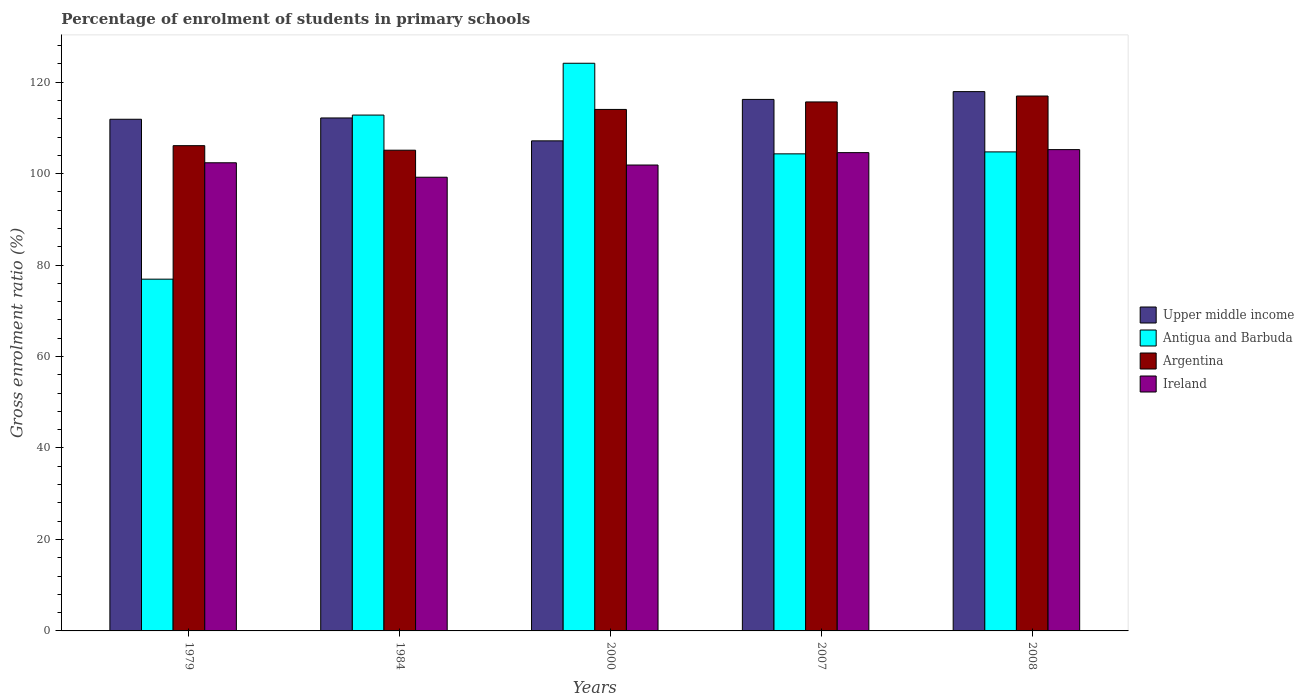Are the number of bars per tick equal to the number of legend labels?
Ensure brevity in your answer.  Yes. How many bars are there on the 4th tick from the left?
Provide a succinct answer. 4. What is the label of the 4th group of bars from the left?
Your answer should be compact. 2007. In how many cases, is the number of bars for a given year not equal to the number of legend labels?
Offer a terse response. 0. What is the percentage of students enrolled in primary schools in Ireland in 2008?
Your answer should be very brief. 105.25. Across all years, what is the maximum percentage of students enrolled in primary schools in Antigua and Barbuda?
Ensure brevity in your answer.  124.13. Across all years, what is the minimum percentage of students enrolled in primary schools in Upper middle income?
Offer a very short reply. 107.16. What is the total percentage of students enrolled in primary schools in Argentina in the graph?
Keep it short and to the point. 557.9. What is the difference between the percentage of students enrolled in primary schools in Upper middle income in 1984 and that in 2008?
Your answer should be compact. -5.76. What is the difference between the percentage of students enrolled in primary schools in Antigua and Barbuda in 2007 and the percentage of students enrolled in primary schools in Upper middle income in 1979?
Give a very brief answer. -7.56. What is the average percentage of students enrolled in primary schools in Ireland per year?
Your answer should be very brief. 102.66. In the year 2007, what is the difference between the percentage of students enrolled in primary schools in Antigua and Barbuda and percentage of students enrolled in primary schools in Ireland?
Make the answer very short. -0.27. In how many years, is the percentage of students enrolled in primary schools in Argentina greater than 64 %?
Ensure brevity in your answer.  5. What is the ratio of the percentage of students enrolled in primary schools in Antigua and Barbuda in 1979 to that in 1984?
Make the answer very short. 0.68. Is the percentage of students enrolled in primary schools in Upper middle income in 2000 less than that in 2007?
Offer a terse response. Yes. Is the difference between the percentage of students enrolled in primary schools in Antigua and Barbuda in 1984 and 2007 greater than the difference between the percentage of students enrolled in primary schools in Ireland in 1984 and 2007?
Offer a terse response. Yes. What is the difference between the highest and the second highest percentage of students enrolled in primary schools in Antigua and Barbuda?
Offer a very short reply. 11.33. What is the difference between the highest and the lowest percentage of students enrolled in primary schools in Ireland?
Offer a terse response. 6.04. Is the sum of the percentage of students enrolled in primary schools in Ireland in 1984 and 2000 greater than the maximum percentage of students enrolled in primary schools in Antigua and Barbuda across all years?
Your answer should be compact. Yes. What does the 1st bar from the left in 1984 represents?
Offer a very short reply. Upper middle income. What does the 4th bar from the right in 1979 represents?
Your response must be concise. Upper middle income. Is it the case that in every year, the sum of the percentage of students enrolled in primary schools in Antigua and Barbuda and percentage of students enrolled in primary schools in Upper middle income is greater than the percentage of students enrolled in primary schools in Ireland?
Give a very brief answer. Yes. Are all the bars in the graph horizontal?
Your answer should be compact. No. Does the graph contain grids?
Your response must be concise. No. How many legend labels are there?
Ensure brevity in your answer.  4. How are the legend labels stacked?
Give a very brief answer. Vertical. What is the title of the graph?
Offer a terse response. Percentage of enrolment of students in primary schools. Does "Macedonia" appear as one of the legend labels in the graph?
Your answer should be very brief. No. What is the Gross enrolment ratio (%) in Upper middle income in 1979?
Your response must be concise. 111.88. What is the Gross enrolment ratio (%) in Antigua and Barbuda in 1979?
Offer a terse response. 76.92. What is the Gross enrolment ratio (%) of Argentina in 1979?
Your response must be concise. 106.11. What is the Gross enrolment ratio (%) in Ireland in 1979?
Offer a terse response. 102.37. What is the Gross enrolment ratio (%) of Upper middle income in 1984?
Your response must be concise. 112.17. What is the Gross enrolment ratio (%) in Antigua and Barbuda in 1984?
Offer a terse response. 112.8. What is the Gross enrolment ratio (%) in Argentina in 1984?
Offer a terse response. 105.12. What is the Gross enrolment ratio (%) of Ireland in 1984?
Make the answer very short. 99.21. What is the Gross enrolment ratio (%) of Upper middle income in 2000?
Give a very brief answer. 107.16. What is the Gross enrolment ratio (%) of Antigua and Barbuda in 2000?
Your answer should be compact. 124.13. What is the Gross enrolment ratio (%) in Argentina in 2000?
Your response must be concise. 114.03. What is the Gross enrolment ratio (%) of Ireland in 2000?
Offer a very short reply. 101.88. What is the Gross enrolment ratio (%) of Upper middle income in 2007?
Your response must be concise. 116.22. What is the Gross enrolment ratio (%) in Antigua and Barbuda in 2007?
Give a very brief answer. 104.32. What is the Gross enrolment ratio (%) in Argentina in 2007?
Your response must be concise. 115.67. What is the Gross enrolment ratio (%) of Ireland in 2007?
Provide a succinct answer. 104.59. What is the Gross enrolment ratio (%) in Upper middle income in 2008?
Your answer should be compact. 117.93. What is the Gross enrolment ratio (%) in Antigua and Barbuda in 2008?
Keep it short and to the point. 104.75. What is the Gross enrolment ratio (%) of Argentina in 2008?
Ensure brevity in your answer.  116.96. What is the Gross enrolment ratio (%) of Ireland in 2008?
Offer a very short reply. 105.25. Across all years, what is the maximum Gross enrolment ratio (%) in Upper middle income?
Provide a succinct answer. 117.93. Across all years, what is the maximum Gross enrolment ratio (%) in Antigua and Barbuda?
Your answer should be very brief. 124.13. Across all years, what is the maximum Gross enrolment ratio (%) of Argentina?
Offer a terse response. 116.96. Across all years, what is the maximum Gross enrolment ratio (%) in Ireland?
Your response must be concise. 105.25. Across all years, what is the minimum Gross enrolment ratio (%) of Upper middle income?
Provide a short and direct response. 107.16. Across all years, what is the minimum Gross enrolment ratio (%) of Antigua and Barbuda?
Your answer should be compact. 76.92. Across all years, what is the minimum Gross enrolment ratio (%) in Argentina?
Give a very brief answer. 105.12. Across all years, what is the minimum Gross enrolment ratio (%) of Ireland?
Give a very brief answer. 99.21. What is the total Gross enrolment ratio (%) of Upper middle income in the graph?
Give a very brief answer. 565.37. What is the total Gross enrolment ratio (%) in Antigua and Barbuda in the graph?
Your answer should be very brief. 522.91. What is the total Gross enrolment ratio (%) in Argentina in the graph?
Keep it short and to the point. 557.9. What is the total Gross enrolment ratio (%) of Ireland in the graph?
Give a very brief answer. 513.29. What is the difference between the Gross enrolment ratio (%) in Upper middle income in 1979 and that in 1984?
Keep it short and to the point. -0.29. What is the difference between the Gross enrolment ratio (%) of Antigua and Barbuda in 1979 and that in 1984?
Provide a succinct answer. -35.88. What is the difference between the Gross enrolment ratio (%) of Ireland in 1979 and that in 1984?
Your answer should be compact. 3.16. What is the difference between the Gross enrolment ratio (%) of Upper middle income in 1979 and that in 2000?
Ensure brevity in your answer.  4.72. What is the difference between the Gross enrolment ratio (%) of Antigua and Barbuda in 1979 and that in 2000?
Ensure brevity in your answer.  -47.21. What is the difference between the Gross enrolment ratio (%) in Argentina in 1979 and that in 2000?
Ensure brevity in your answer.  -7.92. What is the difference between the Gross enrolment ratio (%) of Ireland in 1979 and that in 2000?
Offer a terse response. 0.49. What is the difference between the Gross enrolment ratio (%) of Upper middle income in 1979 and that in 2007?
Offer a very short reply. -4.34. What is the difference between the Gross enrolment ratio (%) of Antigua and Barbuda in 1979 and that in 2007?
Give a very brief answer. -27.4. What is the difference between the Gross enrolment ratio (%) of Argentina in 1979 and that in 2007?
Keep it short and to the point. -9.56. What is the difference between the Gross enrolment ratio (%) of Ireland in 1979 and that in 2007?
Give a very brief answer. -2.22. What is the difference between the Gross enrolment ratio (%) of Upper middle income in 1979 and that in 2008?
Make the answer very short. -6.05. What is the difference between the Gross enrolment ratio (%) in Antigua and Barbuda in 1979 and that in 2008?
Your answer should be very brief. -27.83. What is the difference between the Gross enrolment ratio (%) of Argentina in 1979 and that in 2008?
Offer a terse response. -10.85. What is the difference between the Gross enrolment ratio (%) of Ireland in 1979 and that in 2008?
Make the answer very short. -2.88. What is the difference between the Gross enrolment ratio (%) in Upper middle income in 1984 and that in 2000?
Your answer should be very brief. 5. What is the difference between the Gross enrolment ratio (%) of Antigua and Barbuda in 1984 and that in 2000?
Provide a succinct answer. -11.33. What is the difference between the Gross enrolment ratio (%) in Argentina in 1984 and that in 2000?
Your answer should be compact. -8.91. What is the difference between the Gross enrolment ratio (%) in Ireland in 1984 and that in 2000?
Your answer should be compact. -2.67. What is the difference between the Gross enrolment ratio (%) of Upper middle income in 1984 and that in 2007?
Keep it short and to the point. -4.06. What is the difference between the Gross enrolment ratio (%) of Antigua and Barbuda in 1984 and that in 2007?
Your answer should be very brief. 8.48. What is the difference between the Gross enrolment ratio (%) in Argentina in 1984 and that in 2007?
Make the answer very short. -10.55. What is the difference between the Gross enrolment ratio (%) of Ireland in 1984 and that in 2007?
Make the answer very short. -5.38. What is the difference between the Gross enrolment ratio (%) of Upper middle income in 1984 and that in 2008?
Your answer should be very brief. -5.76. What is the difference between the Gross enrolment ratio (%) in Antigua and Barbuda in 1984 and that in 2008?
Make the answer very short. 8.05. What is the difference between the Gross enrolment ratio (%) of Argentina in 1984 and that in 2008?
Your answer should be compact. -11.85. What is the difference between the Gross enrolment ratio (%) of Ireland in 1984 and that in 2008?
Make the answer very short. -6.04. What is the difference between the Gross enrolment ratio (%) of Upper middle income in 2000 and that in 2007?
Provide a succinct answer. -9.06. What is the difference between the Gross enrolment ratio (%) in Antigua and Barbuda in 2000 and that in 2007?
Offer a terse response. 19.81. What is the difference between the Gross enrolment ratio (%) of Argentina in 2000 and that in 2007?
Provide a short and direct response. -1.64. What is the difference between the Gross enrolment ratio (%) of Ireland in 2000 and that in 2007?
Give a very brief answer. -2.71. What is the difference between the Gross enrolment ratio (%) of Upper middle income in 2000 and that in 2008?
Your answer should be very brief. -10.77. What is the difference between the Gross enrolment ratio (%) in Antigua and Barbuda in 2000 and that in 2008?
Offer a very short reply. 19.38. What is the difference between the Gross enrolment ratio (%) of Argentina in 2000 and that in 2008?
Provide a short and direct response. -2.93. What is the difference between the Gross enrolment ratio (%) in Ireland in 2000 and that in 2008?
Your answer should be compact. -3.37. What is the difference between the Gross enrolment ratio (%) of Upper middle income in 2007 and that in 2008?
Offer a terse response. -1.7. What is the difference between the Gross enrolment ratio (%) of Antigua and Barbuda in 2007 and that in 2008?
Offer a terse response. -0.43. What is the difference between the Gross enrolment ratio (%) of Argentina in 2007 and that in 2008?
Your response must be concise. -1.29. What is the difference between the Gross enrolment ratio (%) of Ireland in 2007 and that in 2008?
Make the answer very short. -0.66. What is the difference between the Gross enrolment ratio (%) in Upper middle income in 1979 and the Gross enrolment ratio (%) in Antigua and Barbuda in 1984?
Your answer should be compact. -0.92. What is the difference between the Gross enrolment ratio (%) in Upper middle income in 1979 and the Gross enrolment ratio (%) in Argentina in 1984?
Offer a very short reply. 6.76. What is the difference between the Gross enrolment ratio (%) of Upper middle income in 1979 and the Gross enrolment ratio (%) of Ireland in 1984?
Your answer should be very brief. 12.67. What is the difference between the Gross enrolment ratio (%) of Antigua and Barbuda in 1979 and the Gross enrolment ratio (%) of Argentina in 1984?
Give a very brief answer. -28.2. What is the difference between the Gross enrolment ratio (%) of Antigua and Barbuda in 1979 and the Gross enrolment ratio (%) of Ireland in 1984?
Offer a terse response. -22.29. What is the difference between the Gross enrolment ratio (%) of Argentina in 1979 and the Gross enrolment ratio (%) of Ireland in 1984?
Provide a succinct answer. 6.9. What is the difference between the Gross enrolment ratio (%) of Upper middle income in 1979 and the Gross enrolment ratio (%) of Antigua and Barbuda in 2000?
Your answer should be compact. -12.25. What is the difference between the Gross enrolment ratio (%) in Upper middle income in 1979 and the Gross enrolment ratio (%) in Argentina in 2000?
Keep it short and to the point. -2.15. What is the difference between the Gross enrolment ratio (%) of Upper middle income in 1979 and the Gross enrolment ratio (%) of Ireland in 2000?
Provide a succinct answer. 10.01. What is the difference between the Gross enrolment ratio (%) in Antigua and Barbuda in 1979 and the Gross enrolment ratio (%) in Argentina in 2000?
Your answer should be compact. -37.12. What is the difference between the Gross enrolment ratio (%) of Antigua and Barbuda in 1979 and the Gross enrolment ratio (%) of Ireland in 2000?
Your response must be concise. -24.96. What is the difference between the Gross enrolment ratio (%) of Argentina in 1979 and the Gross enrolment ratio (%) of Ireland in 2000?
Offer a terse response. 4.23. What is the difference between the Gross enrolment ratio (%) in Upper middle income in 1979 and the Gross enrolment ratio (%) in Antigua and Barbuda in 2007?
Provide a short and direct response. 7.56. What is the difference between the Gross enrolment ratio (%) of Upper middle income in 1979 and the Gross enrolment ratio (%) of Argentina in 2007?
Make the answer very short. -3.79. What is the difference between the Gross enrolment ratio (%) of Upper middle income in 1979 and the Gross enrolment ratio (%) of Ireland in 2007?
Your answer should be compact. 7.3. What is the difference between the Gross enrolment ratio (%) in Antigua and Barbuda in 1979 and the Gross enrolment ratio (%) in Argentina in 2007?
Make the answer very short. -38.76. What is the difference between the Gross enrolment ratio (%) of Antigua and Barbuda in 1979 and the Gross enrolment ratio (%) of Ireland in 2007?
Your answer should be compact. -27.67. What is the difference between the Gross enrolment ratio (%) of Argentina in 1979 and the Gross enrolment ratio (%) of Ireland in 2007?
Your answer should be compact. 1.52. What is the difference between the Gross enrolment ratio (%) in Upper middle income in 1979 and the Gross enrolment ratio (%) in Antigua and Barbuda in 2008?
Ensure brevity in your answer.  7.14. What is the difference between the Gross enrolment ratio (%) in Upper middle income in 1979 and the Gross enrolment ratio (%) in Argentina in 2008?
Provide a short and direct response. -5.08. What is the difference between the Gross enrolment ratio (%) of Upper middle income in 1979 and the Gross enrolment ratio (%) of Ireland in 2008?
Your response must be concise. 6.64. What is the difference between the Gross enrolment ratio (%) of Antigua and Barbuda in 1979 and the Gross enrolment ratio (%) of Argentina in 2008?
Your answer should be compact. -40.05. What is the difference between the Gross enrolment ratio (%) of Antigua and Barbuda in 1979 and the Gross enrolment ratio (%) of Ireland in 2008?
Ensure brevity in your answer.  -28.33. What is the difference between the Gross enrolment ratio (%) in Argentina in 1979 and the Gross enrolment ratio (%) in Ireland in 2008?
Ensure brevity in your answer.  0.86. What is the difference between the Gross enrolment ratio (%) of Upper middle income in 1984 and the Gross enrolment ratio (%) of Antigua and Barbuda in 2000?
Give a very brief answer. -11.96. What is the difference between the Gross enrolment ratio (%) of Upper middle income in 1984 and the Gross enrolment ratio (%) of Argentina in 2000?
Offer a terse response. -1.86. What is the difference between the Gross enrolment ratio (%) in Upper middle income in 1984 and the Gross enrolment ratio (%) in Ireland in 2000?
Ensure brevity in your answer.  10.29. What is the difference between the Gross enrolment ratio (%) in Antigua and Barbuda in 1984 and the Gross enrolment ratio (%) in Argentina in 2000?
Offer a terse response. -1.23. What is the difference between the Gross enrolment ratio (%) of Antigua and Barbuda in 1984 and the Gross enrolment ratio (%) of Ireland in 2000?
Provide a short and direct response. 10.92. What is the difference between the Gross enrolment ratio (%) in Argentina in 1984 and the Gross enrolment ratio (%) in Ireland in 2000?
Give a very brief answer. 3.24. What is the difference between the Gross enrolment ratio (%) in Upper middle income in 1984 and the Gross enrolment ratio (%) in Antigua and Barbuda in 2007?
Give a very brief answer. 7.85. What is the difference between the Gross enrolment ratio (%) of Upper middle income in 1984 and the Gross enrolment ratio (%) of Argentina in 2007?
Make the answer very short. -3.5. What is the difference between the Gross enrolment ratio (%) in Upper middle income in 1984 and the Gross enrolment ratio (%) in Ireland in 2007?
Make the answer very short. 7.58. What is the difference between the Gross enrolment ratio (%) in Antigua and Barbuda in 1984 and the Gross enrolment ratio (%) in Argentina in 2007?
Ensure brevity in your answer.  -2.87. What is the difference between the Gross enrolment ratio (%) in Antigua and Barbuda in 1984 and the Gross enrolment ratio (%) in Ireland in 2007?
Your response must be concise. 8.21. What is the difference between the Gross enrolment ratio (%) in Argentina in 1984 and the Gross enrolment ratio (%) in Ireland in 2007?
Your answer should be compact. 0.53. What is the difference between the Gross enrolment ratio (%) in Upper middle income in 1984 and the Gross enrolment ratio (%) in Antigua and Barbuda in 2008?
Provide a succinct answer. 7.42. What is the difference between the Gross enrolment ratio (%) of Upper middle income in 1984 and the Gross enrolment ratio (%) of Argentina in 2008?
Provide a succinct answer. -4.8. What is the difference between the Gross enrolment ratio (%) of Upper middle income in 1984 and the Gross enrolment ratio (%) of Ireland in 2008?
Ensure brevity in your answer.  6.92. What is the difference between the Gross enrolment ratio (%) in Antigua and Barbuda in 1984 and the Gross enrolment ratio (%) in Argentina in 2008?
Ensure brevity in your answer.  -4.16. What is the difference between the Gross enrolment ratio (%) in Antigua and Barbuda in 1984 and the Gross enrolment ratio (%) in Ireland in 2008?
Make the answer very short. 7.55. What is the difference between the Gross enrolment ratio (%) of Argentina in 1984 and the Gross enrolment ratio (%) of Ireland in 2008?
Keep it short and to the point. -0.13. What is the difference between the Gross enrolment ratio (%) in Upper middle income in 2000 and the Gross enrolment ratio (%) in Antigua and Barbuda in 2007?
Ensure brevity in your answer.  2.85. What is the difference between the Gross enrolment ratio (%) of Upper middle income in 2000 and the Gross enrolment ratio (%) of Argentina in 2007?
Provide a succinct answer. -8.51. What is the difference between the Gross enrolment ratio (%) in Upper middle income in 2000 and the Gross enrolment ratio (%) in Ireland in 2007?
Offer a very short reply. 2.58. What is the difference between the Gross enrolment ratio (%) of Antigua and Barbuda in 2000 and the Gross enrolment ratio (%) of Argentina in 2007?
Keep it short and to the point. 8.46. What is the difference between the Gross enrolment ratio (%) of Antigua and Barbuda in 2000 and the Gross enrolment ratio (%) of Ireland in 2007?
Offer a terse response. 19.54. What is the difference between the Gross enrolment ratio (%) of Argentina in 2000 and the Gross enrolment ratio (%) of Ireland in 2007?
Offer a terse response. 9.45. What is the difference between the Gross enrolment ratio (%) in Upper middle income in 2000 and the Gross enrolment ratio (%) in Antigua and Barbuda in 2008?
Provide a succinct answer. 2.42. What is the difference between the Gross enrolment ratio (%) of Upper middle income in 2000 and the Gross enrolment ratio (%) of Argentina in 2008?
Offer a terse response. -9.8. What is the difference between the Gross enrolment ratio (%) in Upper middle income in 2000 and the Gross enrolment ratio (%) in Ireland in 2008?
Give a very brief answer. 1.92. What is the difference between the Gross enrolment ratio (%) in Antigua and Barbuda in 2000 and the Gross enrolment ratio (%) in Argentina in 2008?
Provide a succinct answer. 7.17. What is the difference between the Gross enrolment ratio (%) in Antigua and Barbuda in 2000 and the Gross enrolment ratio (%) in Ireland in 2008?
Provide a succinct answer. 18.88. What is the difference between the Gross enrolment ratio (%) of Argentina in 2000 and the Gross enrolment ratio (%) of Ireland in 2008?
Your response must be concise. 8.79. What is the difference between the Gross enrolment ratio (%) of Upper middle income in 2007 and the Gross enrolment ratio (%) of Antigua and Barbuda in 2008?
Offer a very short reply. 11.48. What is the difference between the Gross enrolment ratio (%) of Upper middle income in 2007 and the Gross enrolment ratio (%) of Argentina in 2008?
Ensure brevity in your answer.  -0.74. What is the difference between the Gross enrolment ratio (%) of Upper middle income in 2007 and the Gross enrolment ratio (%) of Ireland in 2008?
Provide a short and direct response. 10.98. What is the difference between the Gross enrolment ratio (%) in Antigua and Barbuda in 2007 and the Gross enrolment ratio (%) in Argentina in 2008?
Offer a terse response. -12.65. What is the difference between the Gross enrolment ratio (%) of Antigua and Barbuda in 2007 and the Gross enrolment ratio (%) of Ireland in 2008?
Ensure brevity in your answer.  -0.93. What is the difference between the Gross enrolment ratio (%) in Argentina in 2007 and the Gross enrolment ratio (%) in Ireland in 2008?
Your response must be concise. 10.43. What is the average Gross enrolment ratio (%) in Upper middle income per year?
Keep it short and to the point. 113.07. What is the average Gross enrolment ratio (%) of Antigua and Barbuda per year?
Provide a short and direct response. 104.58. What is the average Gross enrolment ratio (%) of Argentina per year?
Ensure brevity in your answer.  111.58. What is the average Gross enrolment ratio (%) of Ireland per year?
Your answer should be very brief. 102.66. In the year 1979, what is the difference between the Gross enrolment ratio (%) in Upper middle income and Gross enrolment ratio (%) in Antigua and Barbuda?
Your answer should be compact. 34.97. In the year 1979, what is the difference between the Gross enrolment ratio (%) in Upper middle income and Gross enrolment ratio (%) in Argentina?
Your response must be concise. 5.77. In the year 1979, what is the difference between the Gross enrolment ratio (%) in Upper middle income and Gross enrolment ratio (%) in Ireland?
Keep it short and to the point. 9.52. In the year 1979, what is the difference between the Gross enrolment ratio (%) in Antigua and Barbuda and Gross enrolment ratio (%) in Argentina?
Provide a short and direct response. -29.19. In the year 1979, what is the difference between the Gross enrolment ratio (%) in Antigua and Barbuda and Gross enrolment ratio (%) in Ireland?
Offer a very short reply. -25.45. In the year 1979, what is the difference between the Gross enrolment ratio (%) of Argentina and Gross enrolment ratio (%) of Ireland?
Provide a short and direct response. 3.74. In the year 1984, what is the difference between the Gross enrolment ratio (%) of Upper middle income and Gross enrolment ratio (%) of Antigua and Barbuda?
Offer a terse response. -0.63. In the year 1984, what is the difference between the Gross enrolment ratio (%) in Upper middle income and Gross enrolment ratio (%) in Argentina?
Your response must be concise. 7.05. In the year 1984, what is the difference between the Gross enrolment ratio (%) in Upper middle income and Gross enrolment ratio (%) in Ireland?
Offer a terse response. 12.96. In the year 1984, what is the difference between the Gross enrolment ratio (%) in Antigua and Barbuda and Gross enrolment ratio (%) in Argentina?
Offer a terse response. 7.68. In the year 1984, what is the difference between the Gross enrolment ratio (%) of Antigua and Barbuda and Gross enrolment ratio (%) of Ireland?
Offer a very short reply. 13.59. In the year 1984, what is the difference between the Gross enrolment ratio (%) in Argentina and Gross enrolment ratio (%) in Ireland?
Your response must be concise. 5.91. In the year 2000, what is the difference between the Gross enrolment ratio (%) of Upper middle income and Gross enrolment ratio (%) of Antigua and Barbuda?
Make the answer very short. -16.97. In the year 2000, what is the difference between the Gross enrolment ratio (%) of Upper middle income and Gross enrolment ratio (%) of Argentina?
Provide a short and direct response. -6.87. In the year 2000, what is the difference between the Gross enrolment ratio (%) of Upper middle income and Gross enrolment ratio (%) of Ireland?
Your response must be concise. 5.29. In the year 2000, what is the difference between the Gross enrolment ratio (%) in Antigua and Barbuda and Gross enrolment ratio (%) in Argentina?
Offer a terse response. 10.1. In the year 2000, what is the difference between the Gross enrolment ratio (%) of Antigua and Barbuda and Gross enrolment ratio (%) of Ireland?
Your response must be concise. 22.25. In the year 2000, what is the difference between the Gross enrolment ratio (%) in Argentina and Gross enrolment ratio (%) in Ireland?
Ensure brevity in your answer.  12.15. In the year 2007, what is the difference between the Gross enrolment ratio (%) in Upper middle income and Gross enrolment ratio (%) in Antigua and Barbuda?
Your answer should be compact. 11.91. In the year 2007, what is the difference between the Gross enrolment ratio (%) of Upper middle income and Gross enrolment ratio (%) of Argentina?
Keep it short and to the point. 0.55. In the year 2007, what is the difference between the Gross enrolment ratio (%) in Upper middle income and Gross enrolment ratio (%) in Ireland?
Give a very brief answer. 11.64. In the year 2007, what is the difference between the Gross enrolment ratio (%) in Antigua and Barbuda and Gross enrolment ratio (%) in Argentina?
Keep it short and to the point. -11.35. In the year 2007, what is the difference between the Gross enrolment ratio (%) of Antigua and Barbuda and Gross enrolment ratio (%) of Ireland?
Keep it short and to the point. -0.27. In the year 2007, what is the difference between the Gross enrolment ratio (%) in Argentina and Gross enrolment ratio (%) in Ireland?
Provide a short and direct response. 11.09. In the year 2008, what is the difference between the Gross enrolment ratio (%) of Upper middle income and Gross enrolment ratio (%) of Antigua and Barbuda?
Make the answer very short. 13.18. In the year 2008, what is the difference between the Gross enrolment ratio (%) of Upper middle income and Gross enrolment ratio (%) of Argentina?
Provide a succinct answer. 0.97. In the year 2008, what is the difference between the Gross enrolment ratio (%) of Upper middle income and Gross enrolment ratio (%) of Ireland?
Ensure brevity in your answer.  12.68. In the year 2008, what is the difference between the Gross enrolment ratio (%) of Antigua and Barbuda and Gross enrolment ratio (%) of Argentina?
Your answer should be compact. -12.22. In the year 2008, what is the difference between the Gross enrolment ratio (%) in Argentina and Gross enrolment ratio (%) in Ireland?
Provide a short and direct response. 11.72. What is the ratio of the Gross enrolment ratio (%) of Antigua and Barbuda in 1979 to that in 1984?
Offer a terse response. 0.68. What is the ratio of the Gross enrolment ratio (%) in Argentina in 1979 to that in 1984?
Make the answer very short. 1.01. What is the ratio of the Gross enrolment ratio (%) in Ireland in 1979 to that in 1984?
Provide a succinct answer. 1.03. What is the ratio of the Gross enrolment ratio (%) in Upper middle income in 1979 to that in 2000?
Make the answer very short. 1.04. What is the ratio of the Gross enrolment ratio (%) in Antigua and Barbuda in 1979 to that in 2000?
Your response must be concise. 0.62. What is the ratio of the Gross enrolment ratio (%) of Argentina in 1979 to that in 2000?
Offer a terse response. 0.93. What is the ratio of the Gross enrolment ratio (%) of Upper middle income in 1979 to that in 2007?
Keep it short and to the point. 0.96. What is the ratio of the Gross enrolment ratio (%) in Antigua and Barbuda in 1979 to that in 2007?
Your answer should be compact. 0.74. What is the ratio of the Gross enrolment ratio (%) in Argentina in 1979 to that in 2007?
Provide a short and direct response. 0.92. What is the ratio of the Gross enrolment ratio (%) in Ireland in 1979 to that in 2007?
Provide a short and direct response. 0.98. What is the ratio of the Gross enrolment ratio (%) of Upper middle income in 1979 to that in 2008?
Your answer should be compact. 0.95. What is the ratio of the Gross enrolment ratio (%) of Antigua and Barbuda in 1979 to that in 2008?
Your answer should be very brief. 0.73. What is the ratio of the Gross enrolment ratio (%) of Argentina in 1979 to that in 2008?
Offer a very short reply. 0.91. What is the ratio of the Gross enrolment ratio (%) of Ireland in 1979 to that in 2008?
Your answer should be very brief. 0.97. What is the ratio of the Gross enrolment ratio (%) in Upper middle income in 1984 to that in 2000?
Your response must be concise. 1.05. What is the ratio of the Gross enrolment ratio (%) in Antigua and Barbuda in 1984 to that in 2000?
Offer a very short reply. 0.91. What is the ratio of the Gross enrolment ratio (%) of Argentina in 1984 to that in 2000?
Ensure brevity in your answer.  0.92. What is the ratio of the Gross enrolment ratio (%) in Ireland in 1984 to that in 2000?
Provide a succinct answer. 0.97. What is the ratio of the Gross enrolment ratio (%) of Upper middle income in 1984 to that in 2007?
Provide a short and direct response. 0.97. What is the ratio of the Gross enrolment ratio (%) of Antigua and Barbuda in 1984 to that in 2007?
Keep it short and to the point. 1.08. What is the ratio of the Gross enrolment ratio (%) in Argentina in 1984 to that in 2007?
Your response must be concise. 0.91. What is the ratio of the Gross enrolment ratio (%) in Ireland in 1984 to that in 2007?
Provide a succinct answer. 0.95. What is the ratio of the Gross enrolment ratio (%) in Upper middle income in 1984 to that in 2008?
Your answer should be compact. 0.95. What is the ratio of the Gross enrolment ratio (%) in Antigua and Barbuda in 1984 to that in 2008?
Offer a very short reply. 1.08. What is the ratio of the Gross enrolment ratio (%) in Argentina in 1984 to that in 2008?
Provide a short and direct response. 0.9. What is the ratio of the Gross enrolment ratio (%) of Ireland in 1984 to that in 2008?
Provide a succinct answer. 0.94. What is the ratio of the Gross enrolment ratio (%) in Upper middle income in 2000 to that in 2007?
Provide a short and direct response. 0.92. What is the ratio of the Gross enrolment ratio (%) of Antigua and Barbuda in 2000 to that in 2007?
Your answer should be compact. 1.19. What is the ratio of the Gross enrolment ratio (%) in Argentina in 2000 to that in 2007?
Offer a very short reply. 0.99. What is the ratio of the Gross enrolment ratio (%) in Ireland in 2000 to that in 2007?
Offer a terse response. 0.97. What is the ratio of the Gross enrolment ratio (%) of Upper middle income in 2000 to that in 2008?
Keep it short and to the point. 0.91. What is the ratio of the Gross enrolment ratio (%) of Antigua and Barbuda in 2000 to that in 2008?
Offer a terse response. 1.19. What is the ratio of the Gross enrolment ratio (%) in Argentina in 2000 to that in 2008?
Provide a succinct answer. 0.97. What is the ratio of the Gross enrolment ratio (%) in Upper middle income in 2007 to that in 2008?
Your answer should be very brief. 0.99. What is the ratio of the Gross enrolment ratio (%) in Argentina in 2007 to that in 2008?
Your answer should be very brief. 0.99. What is the difference between the highest and the second highest Gross enrolment ratio (%) of Upper middle income?
Ensure brevity in your answer.  1.7. What is the difference between the highest and the second highest Gross enrolment ratio (%) of Antigua and Barbuda?
Ensure brevity in your answer.  11.33. What is the difference between the highest and the second highest Gross enrolment ratio (%) in Argentina?
Provide a short and direct response. 1.29. What is the difference between the highest and the second highest Gross enrolment ratio (%) of Ireland?
Offer a terse response. 0.66. What is the difference between the highest and the lowest Gross enrolment ratio (%) of Upper middle income?
Your response must be concise. 10.77. What is the difference between the highest and the lowest Gross enrolment ratio (%) in Antigua and Barbuda?
Provide a short and direct response. 47.21. What is the difference between the highest and the lowest Gross enrolment ratio (%) in Argentina?
Provide a succinct answer. 11.85. What is the difference between the highest and the lowest Gross enrolment ratio (%) of Ireland?
Offer a terse response. 6.04. 